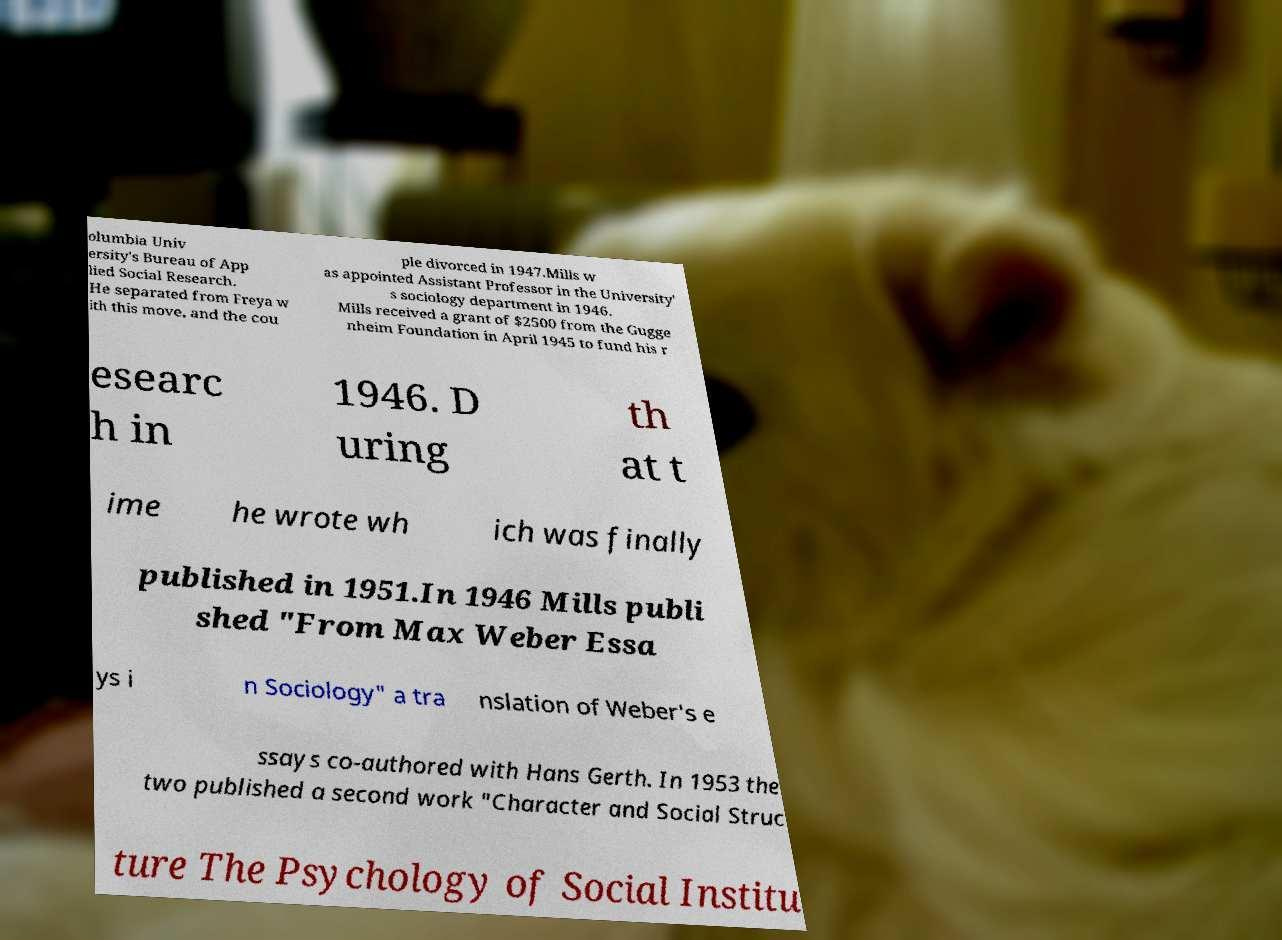Please read and relay the text visible in this image. What does it say? olumbia Univ ersity's Bureau of App lied Social Research. He separated from Freya w ith this move, and the cou ple divorced in 1947.Mills w as appointed Assistant Professor in the University' s sociology department in 1946. Mills received a grant of $2500 from the Gugge nheim Foundation in April 1945 to fund his r esearc h in 1946. D uring th at t ime he wrote wh ich was finally published in 1951.In 1946 Mills publi shed "From Max Weber Essa ys i n Sociology" a tra nslation of Weber's e ssays co-authored with Hans Gerth. In 1953 the two published a second work "Character and Social Struc ture The Psychology of Social Institu 